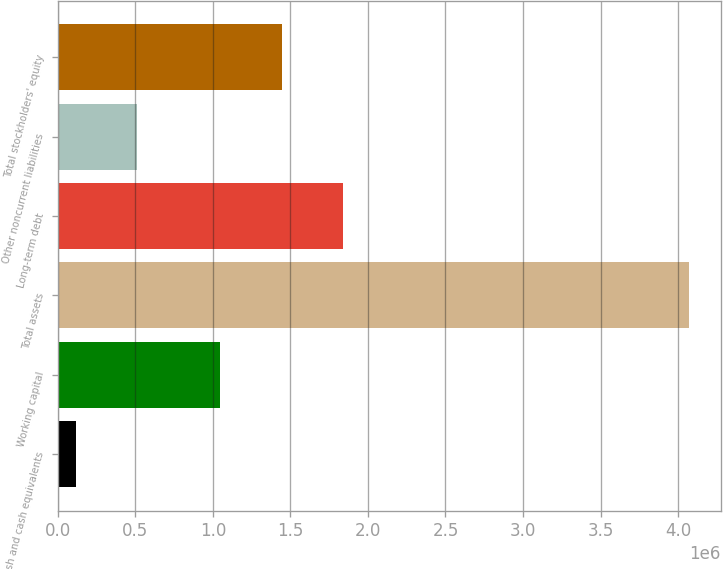Convert chart to OTSL. <chart><loc_0><loc_0><loc_500><loc_500><bar_chart><fcel>Cash and cash equivalents<fcel>Working capital<fcel>Total assets<fcel>Long-term debt<fcel>Other noncurrent liabilities<fcel>Total stockholders' equity<nl><fcel>115863<fcel>1.04762e+06<fcel>4.07218e+06<fcel>1.83889e+06<fcel>511494<fcel>1.44326e+06<nl></chart> 